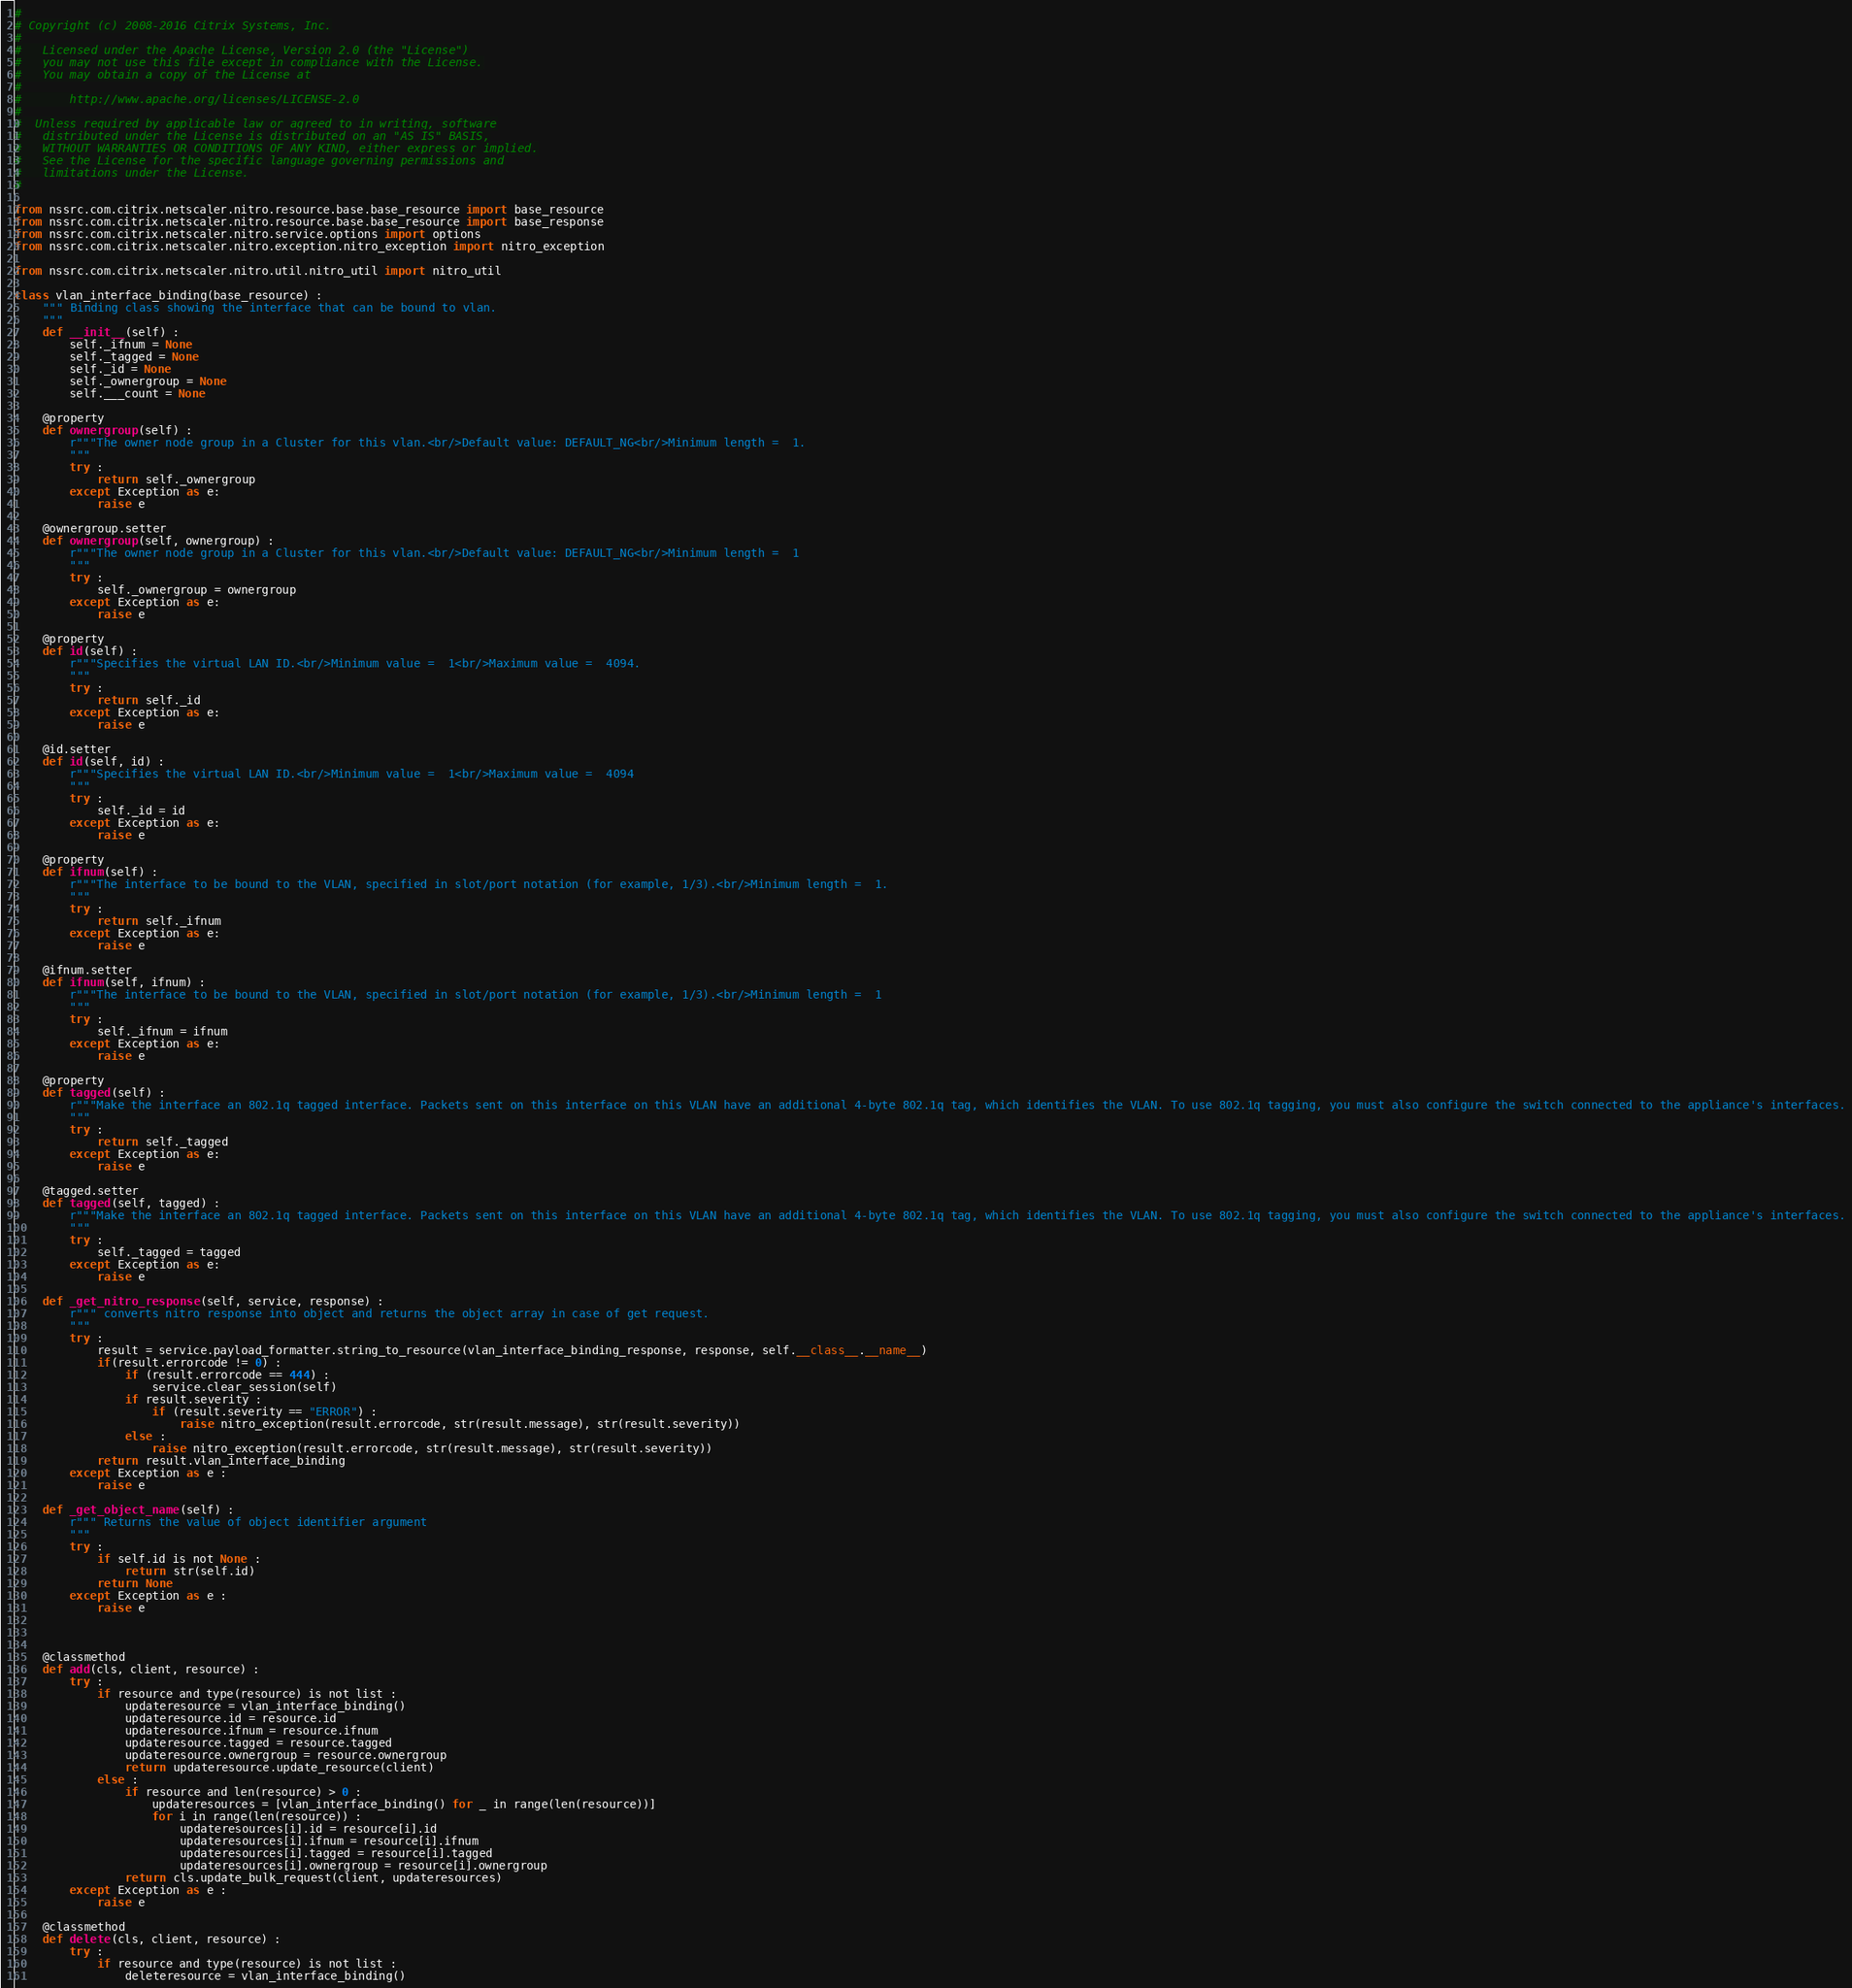<code> <loc_0><loc_0><loc_500><loc_500><_Python_>#
# Copyright (c) 2008-2016 Citrix Systems, Inc.
#
#   Licensed under the Apache License, Version 2.0 (the "License")
#   you may not use this file except in compliance with the License.
#   You may obtain a copy of the License at
#
#       http://www.apache.org/licenses/LICENSE-2.0
#
#  Unless required by applicable law or agreed to in writing, software
#   distributed under the License is distributed on an "AS IS" BASIS,
#   WITHOUT WARRANTIES OR CONDITIONS OF ANY KIND, either express or implied.
#   See the License for the specific language governing permissions and
#   limitations under the License.
#

from nssrc.com.citrix.netscaler.nitro.resource.base.base_resource import base_resource
from nssrc.com.citrix.netscaler.nitro.resource.base.base_resource import base_response
from nssrc.com.citrix.netscaler.nitro.service.options import options
from nssrc.com.citrix.netscaler.nitro.exception.nitro_exception import nitro_exception

from nssrc.com.citrix.netscaler.nitro.util.nitro_util import nitro_util

class vlan_interface_binding(base_resource) :
	""" Binding class showing the interface that can be bound to vlan.
	"""
	def __init__(self) :
		self._ifnum = None
		self._tagged = None
		self._id = None
		self._ownergroup = None
		self.___count = None

	@property
	def ownergroup(self) :
		r"""The owner node group in a Cluster for this vlan.<br/>Default value: DEFAULT_NG<br/>Minimum length =  1.
		"""
		try :
			return self._ownergroup
		except Exception as e:
			raise e

	@ownergroup.setter
	def ownergroup(self, ownergroup) :
		r"""The owner node group in a Cluster for this vlan.<br/>Default value: DEFAULT_NG<br/>Minimum length =  1
		"""
		try :
			self._ownergroup = ownergroup
		except Exception as e:
			raise e

	@property
	def id(self) :
		r"""Specifies the virtual LAN ID.<br/>Minimum value =  1<br/>Maximum value =  4094.
		"""
		try :
			return self._id
		except Exception as e:
			raise e

	@id.setter
	def id(self, id) :
		r"""Specifies the virtual LAN ID.<br/>Minimum value =  1<br/>Maximum value =  4094
		"""
		try :
			self._id = id
		except Exception as e:
			raise e

	@property
	def ifnum(self) :
		r"""The interface to be bound to the VLAN, specified in slot/port notation (for example, 1/3).<br/>Minimum length =  1.
		"""
		try :
			return self._ifnum
		except Exception as e:
			raise e

	@ifnum.setter
	def ifnum(self, ifnum) :
		r"""The interface to be bound to the VLAN, specified in slot/port notation (for example, 1/3).<br/>Minimum length =  1
		"""
		try :
			self._ifnum = ifnum
		except Exception as e:
			raise e

	@property
	def tagged(self) :
		r"""Make the interface an 802.1q tagged interface. Packets sent on this interface on this VLAN have an additional 4-byte 802.1q tag, which identifies the VLAN. To use 802.1q tagging, you must also configure the switch connected to the appliance's interfaces.
		"""
		try :
			return self._tagged
		except Exception as e:
			raise e

	@tagged.setter
	def tagged(self, tagged) :
		r"""Make the interface an 802.1q tagged interface. Packets sent on this interface on this VLAN have an additional 4-byte 802.1q tag, which identifies the VLAN. To use 802.1q tagging, you must also configure the switch connected to the appliance's interfaces.
		"""
		try :
			self._tagged = tagged
		except Exception as e:
			raise e

	def _get_nitro_response(self, service, response) :
		r""" converts nitro response into object and returns the object array in case of get request.
		"""
		try :
			result = service.payload_formatter.string_to_resource(vlan_interface_binding_response, response, self.__class__.__name__)
			if(result.errorcode != 0) :
				if (result.errorcode == 444) :
					service.clear_session(self)
				if result.severity :
					if (result.severity == "ERROR") :
						raise nitro_exception(result.errorcode, str(result.message), str(result.severity))
				else :
					raise nitro_exception(result.errorcode, str(result.message), str(result.severity))
			return result.vlan_interface_binding
		except Exception as e :
			raise e

	def _get_object_name(self) :
		r""" Returns the value of object identifier argument
		"""
		try :
			if self.id is not None :
				return str(self.id)
			return None
		except Exception as e :
			raise e



	@classmethod
	def add(cls, client, resource) :
		try :
			if resource and type(resource) is not list :
				updateresource = vlan_interface_binding()
				updateresource.id = resource.id
				updateresource.ifnum = resource.ifnum
				updateresource.tagged = resource.tagged
				updateresource.ownergroup = resource.ownergroup
				return updateresource.update_resource(client)
			else :
				if resource and len(resource) > 0 :
					updateresources = [vlan_interface_binding() for _ in range(len(resource))]
					for i in range(len(resource)) :
						updateresources[i].id = resource[i].id
						updateresources[i].ifnum = resource[i].ifnum
						updateresources[i].tagged = resource[i].tagged
						updateresources[i].ownergroup = resource[i].ownergroup
				return cls.update_bulk_request(client, updateresources)
		except Exception as e :
			raise e

	@classmethod
	def delete(cls, client, resource) :
		try :
			if resource and type(resource) is not list :
				deleteresource = vlan_interface_binding()</code> 